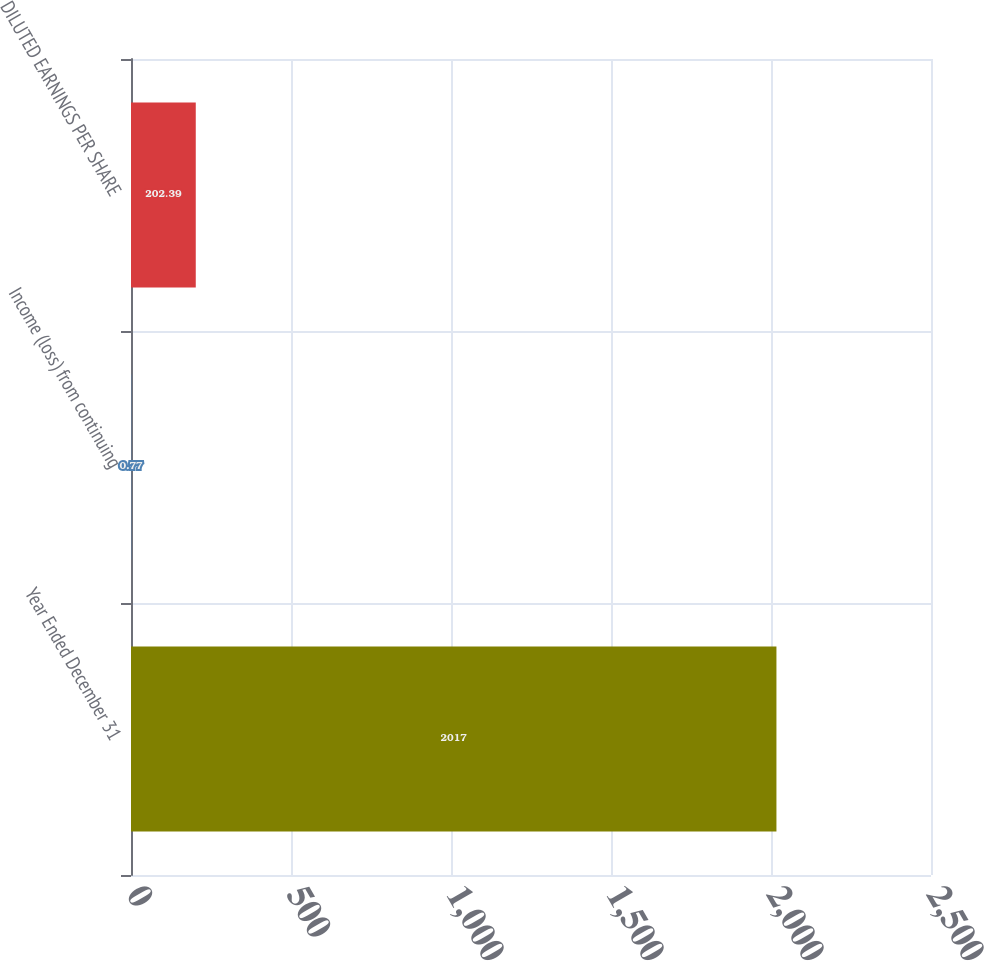Convert chart. <chart><loc_0><loc_0><loc_500><loc_500><bar_chart><fcel>Year Ended December 31<fcel>Income (loss) from continuing<fcel>DILUTED EARNINGS PER SHARE<nl><fcel>2017<fcel>0.77<fcel>202.39<nl></chart> 